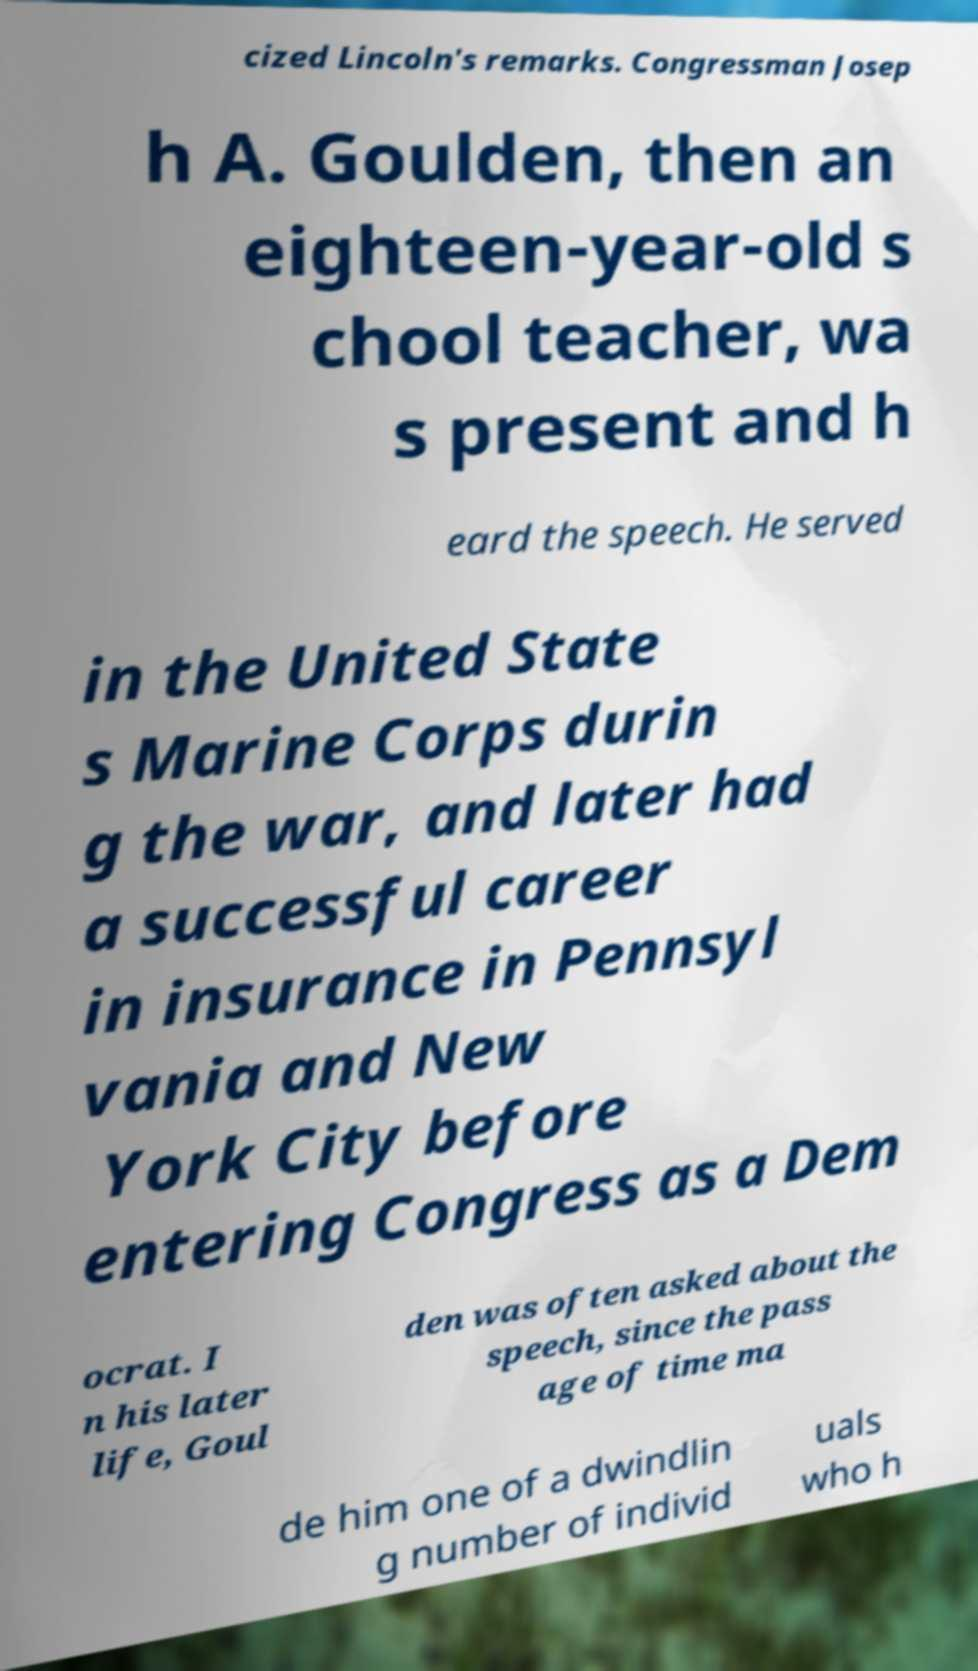Can you accurately transcribe the text from the provided image for me? cized Lincoln's remarks. Congressman Josep h A. Goulden, then an eighteen-year-old s chool teacher, wa s present and h eard the speech. He served in the United State s Marine Corps durin g the war, and later had a successful career in insurance in Pennsyl vania and New York City before entering Congress as a Dem ocrat. I n his later life, Goul den was often asked about the speech, since the pass age of time ma de him one of a dwindlin g number of individ uals who h 